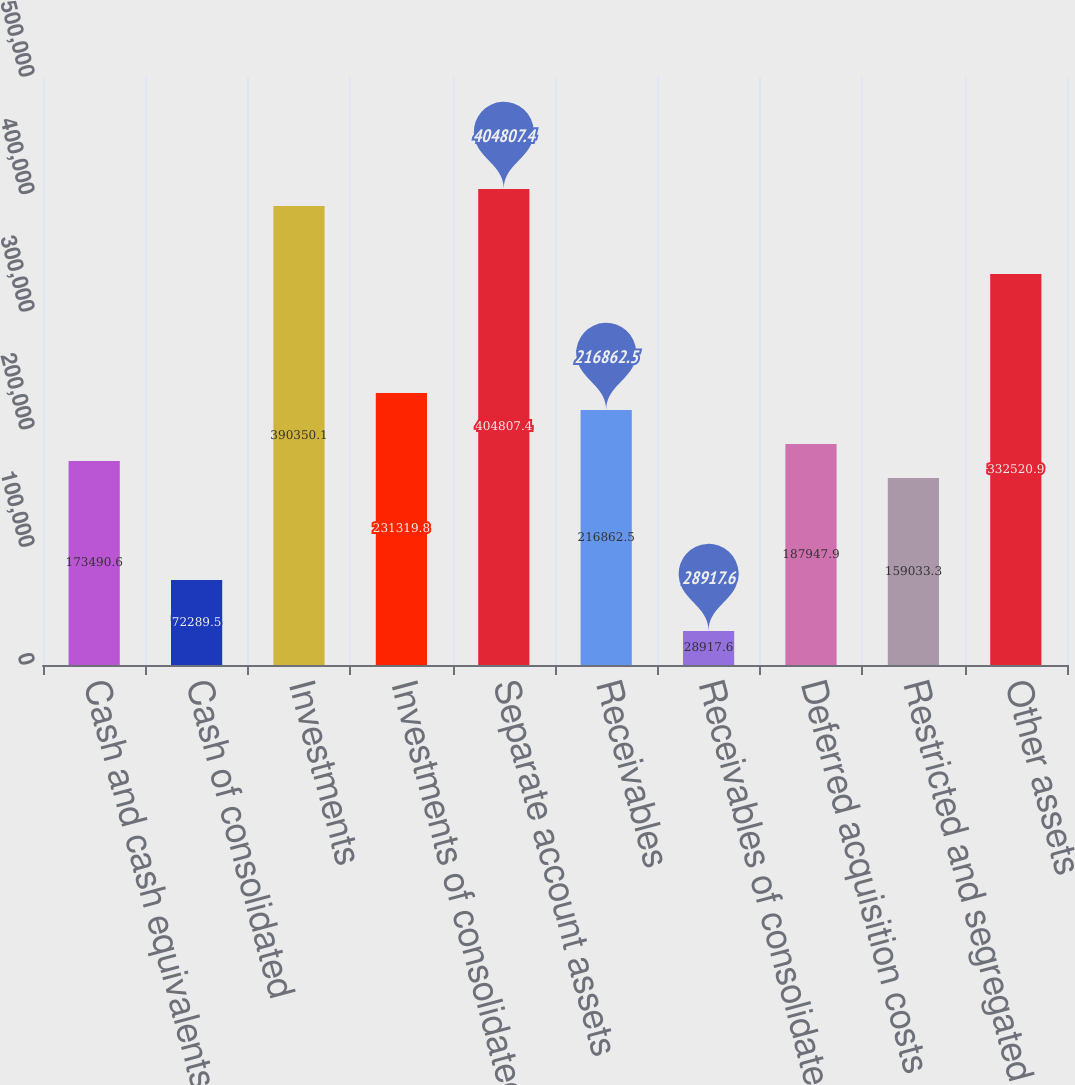Convert chart. <chart><loc_0><loc_0><loc_500><loc_500><bar_chart><fcel>Cash and cash equivalents<fcel>Cash of consolidated<fcel>Investments<fcel>Investments of consolidated<fcel>Separate account assets<fcel>Receivables<fcel>Receivables of consolidated<fcel>Deferred acquisition costs<fcel>Restricted and segregated cash<fcel>Other assets<nl><fcel>173491<fcel>72289.5<fcel>390350<fcel>231320<fcel>404807<fcel>216862<fcel>28917.6<fcel>187948<fcel>159033<fcel>332521<nl></chart> 